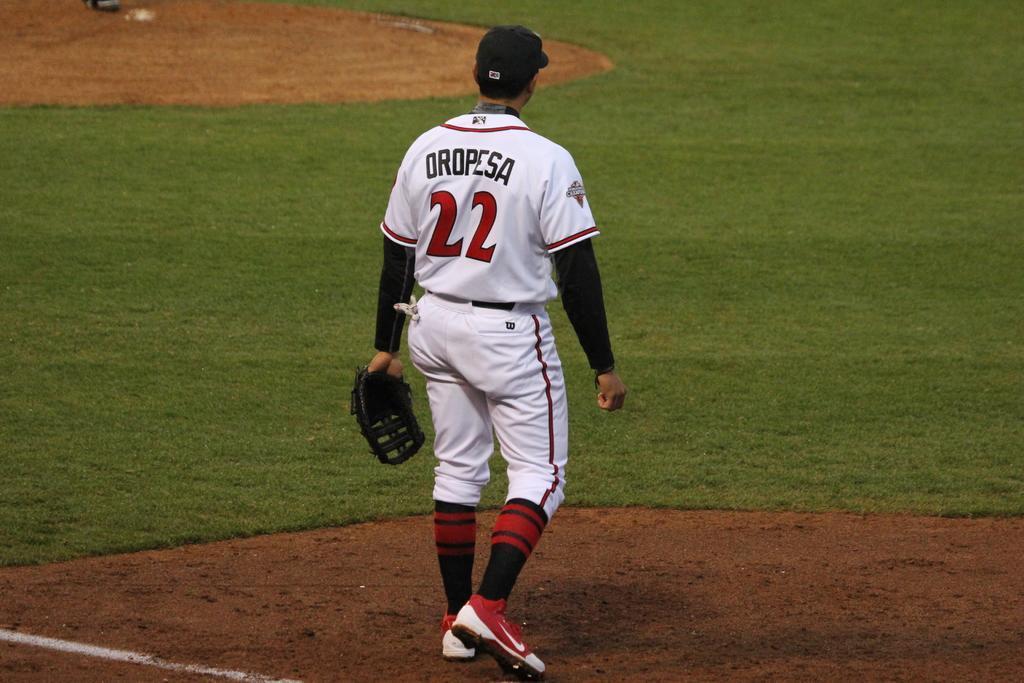<image>
Describe the image concisely. A man in a baseball uniform with the number 22 